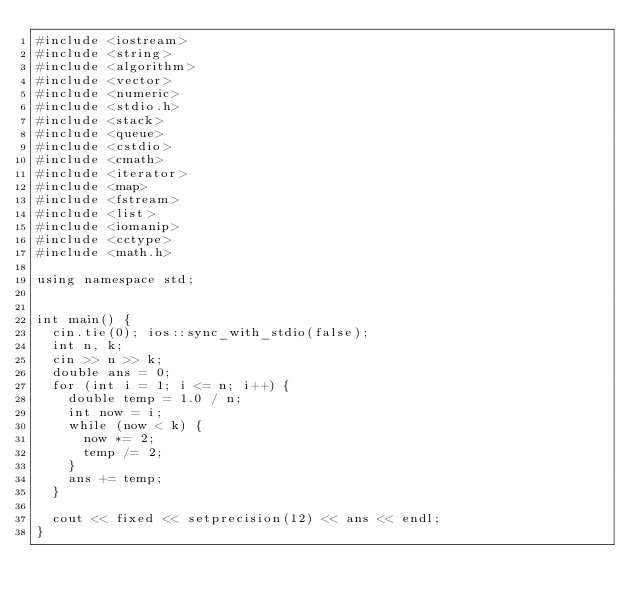<code> <loc_0><loc_0><loc_500><loc_500><_C++_>#include <iostream>
#include <string>
#include <algorithm>
#include <vector>
#include <numeric>
#include <stdio.h>
#include <stack>
#include <queue>
#include <cstdio>
#include <cmath>
#include <iterator>
#include <map>
#include <fstream>
#include <list>
#include <iomanip>
#include <cctype>
#include <math.h>

using namespace std;


int main() {
	cin.tie(0); ios::sync_with_stdio(false);
	int n, k;
	cin >> n >> k;
	double ans = 0;
	for (int i = 1; i <= n; i++) {
		double temp = 1.0 / n;
		int now = i;
		while (now < k) {
			now *= 2;
			temp /= 2;
		}
		ans += temp;
	}

	cout << fixed << setprecision(12) << ans << endl;
}


</code> 